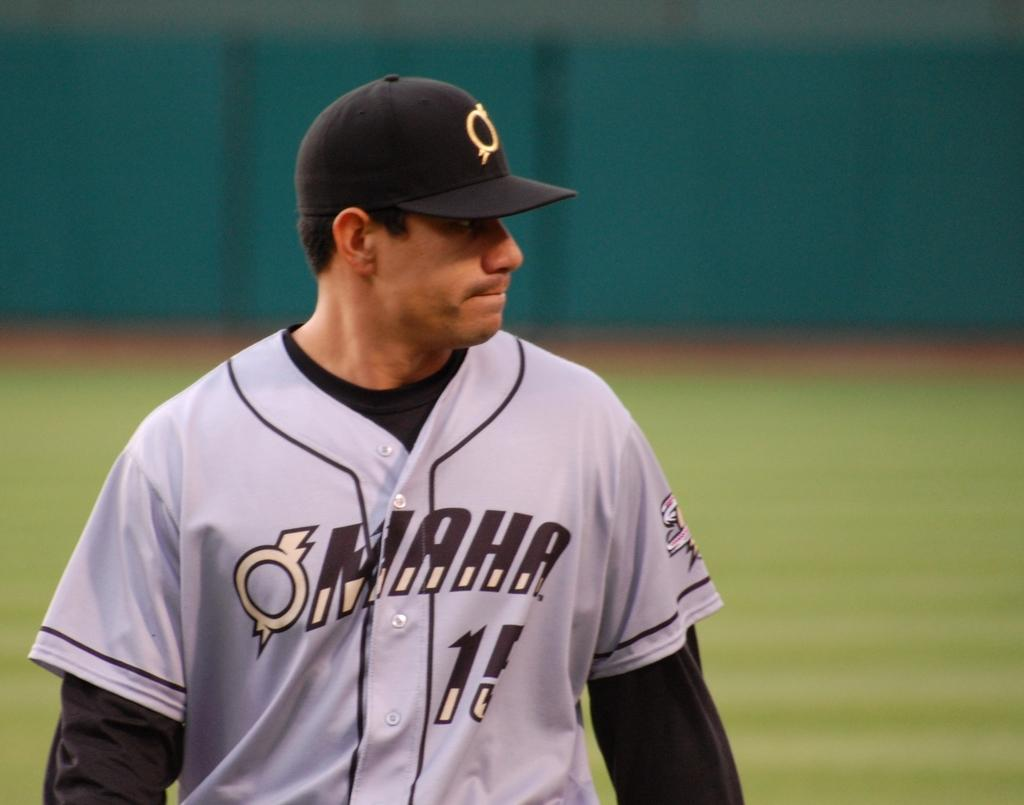<image>
Write a terse but informative summary of the picture. Player wearing a gray Omaha jersey walking on the field. 